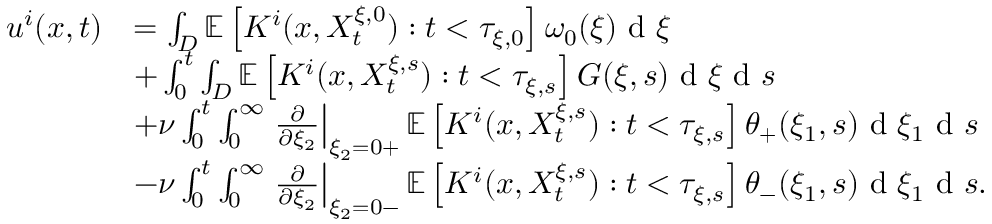<formula> <loc_0><loc_0><loc_500><loc_500>\begin{array} { r l } { u ^ { i } ( x , t ) } & { = \int _ { D } \mathbb { E } \left [ K ^ { i } ( x , X _ { t } ^ { \xi , 0 } ) \colon t < \tau _ { \xi , 0 } \right ] \omega _ { 0 } ( \xi ) d \xi } \\ & { + \int _ { 0 } ^ { t } \int _ { D } \mathbb { E } \left [ K ^ { i } ( x , X _ { t } ^ { \xi , s } ) \colon t < \tau _ { \xi , s } \right ] G ( \xi , s ) d \xi d s } \\ & { + \nu \int _ { 0 } ^ { t } \int _ { 0 } ^ { \infty } \frac { \partial } { \partial \xi _ { 2 } } \right | _ { \xi _ { 2 } = 0 + } \mathbb { E } \left [ K ^ { i } ( x , X _ { t } ^ { \xi , s } ) \colon t < \tau _ { \xi , s } \right ] \theta _ { + } ( \xi _ { 1 } , s ) d \xi _ { 1 } d s } \\ & { - \nu \int _ { 0 } ^ { t } \int _ { 0 } ^ { \infty } \frac { \partial } { \partial \xi _ { 2 } } \right | _ { \xi _ { 2 } = 0 - } \mathbb { E } \left [ K ^ { i } ( x , X _ { t } ^ { \xi , s } ) \colon t < \tau _ { \xi , s } \right ] \theta _ { - } ( \xi _ { 1 } , s ) d \xi _ { 1 } d s . } \end{array}</formula> 